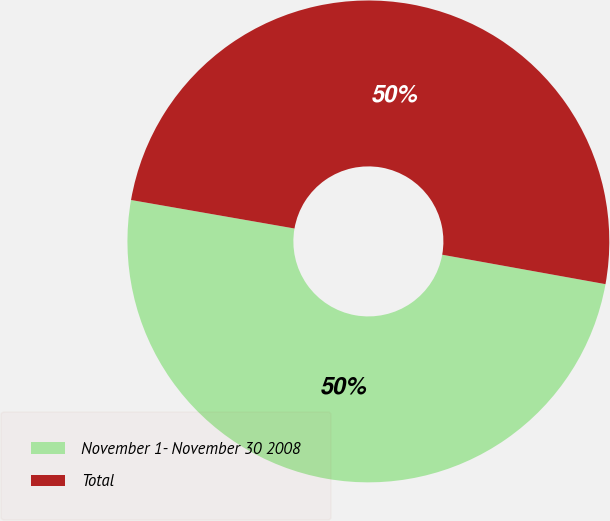Convert chart to OTSL. <chart><loc_0><loc_0><loc_500><loc_500><pie_chart><fcel>November 1- November 30 2008<fcel>Total<nl><fcel>49.91%<fcel>50.09%<nl></chart> 